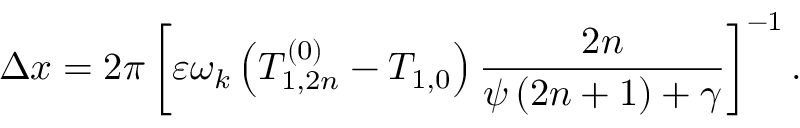<formula> <loc_0><loc_0><loc_500><loc_500>\Delta x = 2 \pi \left [ \varepsilon \omega _ { k } \left ( T _ { 1 , 2 n } ^ { \left ( 0 \right ) } - T _ { 1 , 0 } \right ) \frac { 2 n } { \psi \left ( 2 n + 1 \right ) + \gamma } \right ] ^ { - 1 } .</formula> 